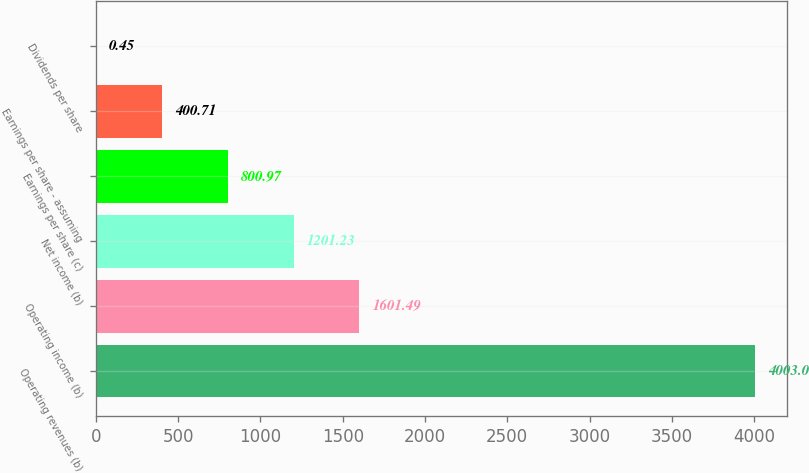Convert chart. <chart><loc_0><loc_0><loc_500><loc_500><bar_chart><fcel>Operating revenues (b)<fcel>Operating income (b)<fcel>Net income (b)<fcel>Earnings per share (c)<fcel>Earnings per share - assuming<fcel>Dividends per share<nl><fcel>4003<fcel>1601.49<fcel>1201.23<fcel>800.97<fcel>400.71<fcel>0.45<nl></chart> 